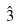Convert formula to latex. <formula><loc_0><loc_0><loc_500><loc_500>\hat { 3 }</formula> 